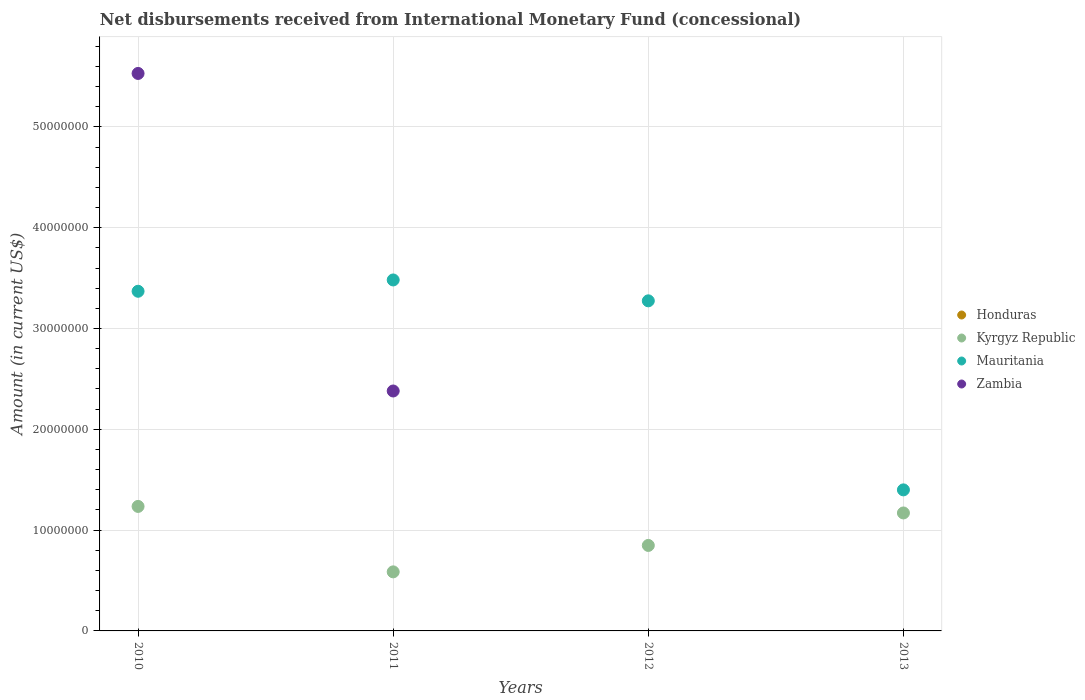Is the number of dotlines equal to the number of legend labels?
Offer a terse response. No. What is the amount of disbursements received from International Monetary Fund in Zambia in 2010?
Provide a short and direct response. 5.53e+07. Across all years, what is the minimum amount of disbursements received from International Monetary Fund in Kyrgyz Republic?
Offer a terse response. 5.86e+06. In which year was the amount of disbursements received from International Monetary Fund in Zambia maximum?
Keep it short and to the point. 2010. What is the total amount of disbursements received from International Monetary Fund in Zambia in the graph?
Provide a short and direct response. 7.91e+07. What is the difference between the amount of disbursements received from International Monetary Fund in Mauritania in 2010 and that in 2013?
Offer a very short reply. 1.97e+07. What is the difference between the amount of disbursements received from International Monetary Fund in Mauritania in 2011 and the amount of disbursements received from International Monetary Fund in Kyrgyz Republic in 2010?
Offer a terse response. 2.25e+07. What is the average amount of disbursements received from International Monetary Fund in Zambia per year?
Make the answer very short. 1.98e+07. In the year 2012, what is the difference between the amount of disbursements received from International Monetary Fund in Mauritania and amount of disbursements received from International Monetary Fund in Kyrgyz Republic?
Offer a very short reply. 2.43e+07. In how many years, is the amount of disbursements received from International Monetary Fund in Kyrgyz Republic greater than 34000000 US$?
Give a very brief answer. 0. What is the ratio of the amount of disbursements received from International Monetary Fund in Kyrgyz Republic in 2012 to that in 2013?
Your answer should be compact. 0.72. Is the difference between the amount of disbursements received from International Monetary Fund in Mauritania in 2010 and 2012 greater than the difference between the amount of disbursements received from International Monetary Fund in Kyrgyz Republic in 2010 and 2012?
Offer a very short reply. No. What is the difference between the highest and the second highest amount of disbursements received from International Monetary Fund in Mauritania?
Your answer should be compact. 1.12e+06. What is the difference between the highest and the lowest amount of disbursements received from International Monetary Fund in Kyrgyz Republic?
Your response must be concise. 6.49e+06. In how many years, is the amount of disbursements received from International Monetary Fund in Zambia greater than the average amount of disbursements received from International Monetary Fund in Zambia taken over all years?
Ensure brevity in your answer.  2. Is the sum of the amount of disbursements received from International Monetary Fund in Kyrgyz Republic in 2010 and 2013 greater than the maximum amount of disbursements received from International Monetary Fund in Honduras across all years?
Keep it short and to the point. Yes. Is it the case that in every year, the sum of the amount of disbursements received from International Monetary Fund in Kyrgyz Republic and amount of disbursements received from International Monetary Fund in Zambia  is greater than the amount of disbursements received from International Monetary Fund in Mauritania?
Offer a terse response. No. Does the amount of disbursements received from International Monetary Fund in Mauritania monotonically increase over the years?
Make the answer very short. No. Is the amount of disbursements received from International Monetary Fund in Mauritania strictly greater than the amount of disbursements received from International Monetary Fund in Honduras over the years?
Give a very brief answer. Yes. How many dotlines are there?
Provide a succinct answer. 3. Are the values on the major ticks of Y-axis written in scientific E-notation?
Provide a succinct answer. No. Where does the legend appear in the graph?
Your answer should be very brief. Center right. How are the legend labels stacked?
Keep it short and to the point. Vertical. What is the title of the graph?
Your answer should be very brief. Net disbursements received from International Monetary Fund (concessional). What is the label or title of the X-axis?
Keep it short and to the point. Years. What is the label or title of the Y-axis?
Offer a terse response. Amount (in current US$). What is the Amount (in current US$) of Kyrgyz Republic in 2010?
Your response must be concise. 1.24e+07. What is the Amount (in current US$) in Mauritania in 2010?
Offer a terse response. 3.37e+07. What is the Amount (in current US$) of Zambia in 2010?
Your answer should be very brief. 5.53e+07. What is the Amount (in current US$) in Honduras in 2011?
Provide a short and direct response. 0. What is the Amount (in current US$) in Kyrgyz Republic in 2011?
Offer a very short reply. 5.86e+06. What is the Amount (in current US$) of Mauritania in 2011?
Ensure brevity in your answer.  3.48e+07. What is the Amount (in current US$) in Zambia in 2011?
Your response must be concise. 2.38e+07. What is the Amount (in current US$) in Honduras in 2012?
Your answer should be very brief. 0. What is the Amount (in current US$) of Kyrgyz Republic in 2012?
Offer a terse response. 8.48e+06. What is the Amount (in current US$) in Mauritania in 2012?
Make the answer very short. 3.27e+07. What is the Amount (in current US$) of Zambia in 2012?
Keep it short and to the point. 0. What is the Amount (in current US$) in Kyrgyz Republic in 2013?
Provide a succinct answer. 1.17e+07. What is the Amount (in current US$) in Mauritania in 2013?
Your response must be concise. 1.40e+07. Across all years, what is the maximum Amount (in current US$) in Kyrgyz Republic?
Offer a terse response. 1.24e+07. Across all years, what is the maximum Amount (in current US$) of Mauritania?
Keep it short and to the point. 3.48e+07. Across all years, what is the maximum Amount (in current US$) in Zambia?
Offer a terse response. 5.53e+07. Across all years, what is the minimum Amount (in current US$) in Kyrgyz Republic?
Your answer should be very brief. 5.86e+06. Across all years, what is the minimum Amount (in current US$) in Mauritania?
Make the answer very short. 1.40e+07. What is the total Amount (in current US$) in Honduras in the graph?
Offer a very short reply. 0. What is the total Amount (in current US$) in Kyrgyz Republic in the graph?
Give a very brief answer. 3.84e+07. What is the total Amount (in current US$) of Mauritania in the graph?
Offer a terse response. 1.15e+08. What is the total Amount (in current US$) in Zambia in the graph?
Keep it short and to the point. 7.91e+07. What is the difference between the Amount (in current US$) in Kyrgyz Republic in 2010 and that in 2011?
Keep it short and to the point. 6.49e+06. What is the difference between the Amount (in current US$) of Mauritania in 2010 and that in 2011?
Ensure brevity in your answer.  -1.12e+06. What is the difference between the Amount (in current US$) of Zambia in 2010 and that in 2011?
Keep it short and to the point. 3.15e+07. What is the difference between the Amount (in current US$) in Kyrgyz Republic in 2010 and that in 2012?
Keep it short and to the point. 3.87e+06. What is the difference between the Amount (in current US$) of Mauritania in 2010 and that in 2012?
Your response must be concise. 9.49e+05. What is the difference between the Amount (in current US$) of Kyrgyz Republic in 2010 and that in 2013?
Keep it short and to the point. 6.48e+05. What is the difference between the Amount (in current US$) of Mauritania in 2010 and that in 2013?
Provide a short and direct response. 1.97e+07. What is the difference between the Amount (in current US$) in Kyrgyz Republic in 2011 and that in 2012?
Keep it short and to the point. -2.62e+06. What is the difference between the Amount (in current US$) in Mauritania in 2011 and that in 2012?
Make the answer very short. 2.07e+06. What is the difference between the Amount (in current US$) in Kyrgyz Republic in 2011 and that in 2013?
Your response must be concise. -5.84e+06. What is the difference between the Amount (in current US$) of Mauritania in 2011 and that in 2013?
Provide a succinct answer. 2.08e+07. What is the difference between the Amount (in current US$) in Kyrgyz Republic in 2012 and that in 2013?
Your answer should be very brief. -3.22e+06. What is the difference between the Amount (in current US$) of Mauritania in 2012 and that in 2013?
Your response must be concise. 1.88e+07. What is the difference between the Amount (in current US$) of Kyrgyz Republic in 2010 and the Amount (in current US$) of Mauritania in 2011?
Your response must be concise. -2.25e+07. What is the difference between the Amount (in current US$) of Kyrgyz Republic in 2010 and the Amount (in current US$) of Zambia in 2011?
Your answer should be very brief. -1.14e+07. What is the difference between the Amount (in current US$) in Mauritania in 2010 and the Amount (in current US$) in Zambia in 2011?
Your response must be concise. 9.89e+06. What is the difference between the Amount (in current US$) of Kyrgyz Republic in 2010 and the Amount (in current US$) of Mauritania in 2012?
Your answer should be very brief. -2.04e+07. What is the difference between the Amount (in current US$) of Kyrgyz Republic in 2010 and the Amount (in current US$) of Mauritania in 2013?
Provide a succinct answer. -1.64e+06. What is the difference between the Amount (in current US$) in Kyrgyz Republic in 2011 and the Amount (in current US$) in Mauritania in 2012?
Your response must be concise. -2.69e+07. What is the difference between the Amount (in current US$) in Kyrgyz Republic in 2011 and the Amount (in current US$) in Mauritania in 2013?
Offer a very short reply. -8.13e+06. What is the difference between the Amount (in current US$) of Kyrgyz Republic in 2012 and the Amount (in current US$) of Mauritania in 2013?
Ensure brevity in your answer.  -5.51e+06. What is the average Amount (in current US$) in Honduras per year?
Offer a very short reply. 0. What is the average Amount (in current US$) of Kyrgyz Republic per year?
Offer a very short reply. 9.60e+06. What is the average Amount (in current US$) of Mauritania per year?
Make the answer very short. 2.88e+07. What is the average Amount (in current US$) in Zambia per year?
Give a very brief answer. 1.98e+07. In the year 2010, what is the difference between the Amount (in current US$) in Kyrgyz Republic and Amount (in current US$) in Mauritania?
Offer a terse response. -2.13e+07. In the year 2010, what is the difference between the Amount (in current US$) in Kyrgyz Republic and Amount (in current US$) in Zambia?
Give a very brief answer. -4.30e+07. In the year 2010, what is the difference between the Amount (in current US$) of Mauritania and Amount (in current US$) of Zambia?
Offer a terse response. -2.16e+07. In the year 2011, what is the difference between the Amount (in current US$) of Kyrgyz Republic and Amount (in current US$) of Mauritania?
Make the answer very short. -2.90e+07. In the year 2011, what is the difference between the Amount (in current US$) of Kyrgyz Republic and Amount (in current US$) of Zambia?
Your answer should be very brief. -1.79e+07. In the year 2011, what is the difference between the Amount (in current US$) of Mauritania and Amount (in current US$) of Zambia?
Offer a very short reply. 1.10e+07. In the year 2012, what is the difference between the Amount (in current US$) in Kyrgyz Republic and Amount (in current US$) in Mauritania?
Provide a short and direct response. -2.43e+07. In the year 2013, what is the difference between the Amount (in current US$) in Kyrgyz Republic and Amount (in current US$) in Mauritania?
Offer a terse response. -2.29e+06. What is the ratio of the Amount (in current US$) in Kyrgyz Republic in 2010 to that in 2011?
Your answer should be compact. 2.11. What is the ratio of the Amount (in current US$) in Mauritania in 2010 to that in 2011?
Your response must be concise. 0.97. What is the ratio of the Amount (in current US$) of Zambia in 2010 to that in 2011?
Offer a terse response. 2.32. What is the ratio of the Amount (in current US$) in Kyrgyz Republic in 2010 to that in 2012?
Your answer should be very brief. 1.46. What is the ratio of the Amount (in current US$) in Kyrgyz Republic in 2010 to that in 2013?
Keep it short and to the point. 1.06. What is the ratio of the Amount (in current US$) of Mauritania in 2010 to that in 2013?
Offer a terse response. 2.41. What is the ratio of the Amount (in current US$) of Kyrgyz Republic in 2011 to that in 2012?
Provide a short and direct response. 0.69. What is the ratio of the Amount (in current US$) in Mauritania in 2011 to that in 2012?
Ensure brevity in your answer.  1.06. What is the ratio of the Amount (in current US$) in Kyrgyz Republic in 2011 to that in 2013?
Offer a terse response. 0.5. What is the ratio of the Amount (in current US$) of Mauritania in 2011 to that in 2013?
Your response must be concise. 2.49. What is the ratio of the Amount (in current US$) of Kyrgyz Republic in 2012 to that in 2013?
Ensure brevity in your answer.  0.72. What is the ratio of the Amount (in current US$) of Mauritania in 2012 to that in 2013?
Offer a terse response. 2.34. What is the difference between the highest and the second highest Amount (in current US$) in Kyrgyz Republic?
Your response must be concise. 6.48e+05. What is the difference between the highest and the second highest Amount (in current US$) in Mauritania?
Provide a short and direct response. 1.12e+06. What is the difference between the highest and the lowest Amount (in current US$) of Kyrgyz Republic?
Your response must be concise. 6.49e+06. What is the difference between the highest and the lowest Amount (in current US$) of Mauritania?
Provide a short and direct response. 2.08e+07. What is the difference between the highest and the lowest Amount (in current US$) in Zambia?
Your response must be concise. 5.53e+07. 